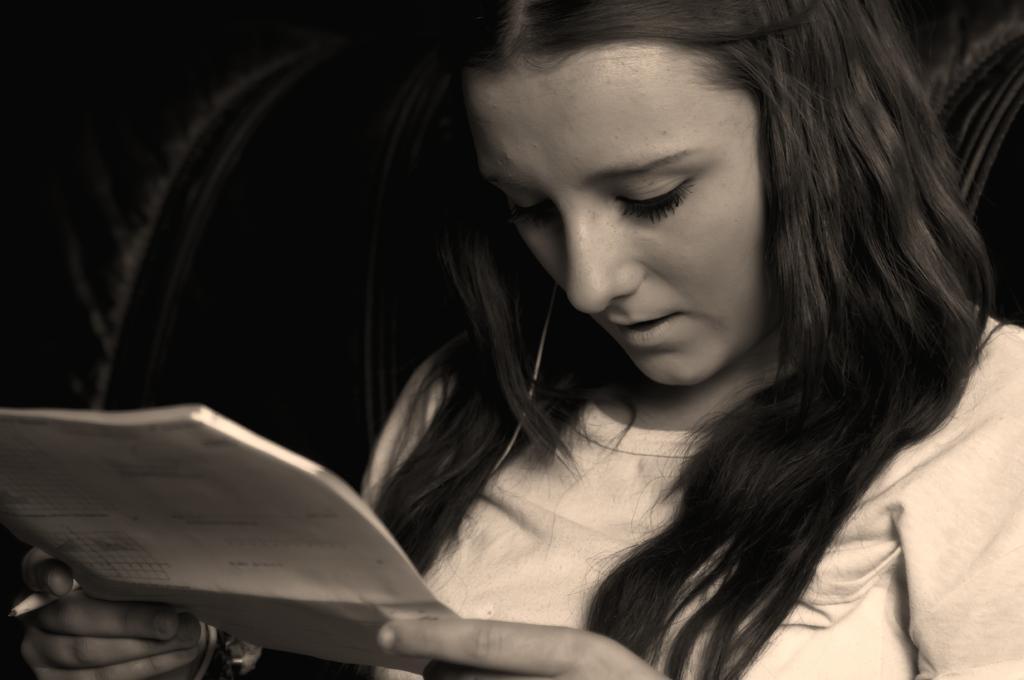How would you summarize this image in a sentence or two? This is a black and white image. Here I can see a woman holding a paper and a pen in the hands and looking at the downwards. The background is in black color. 